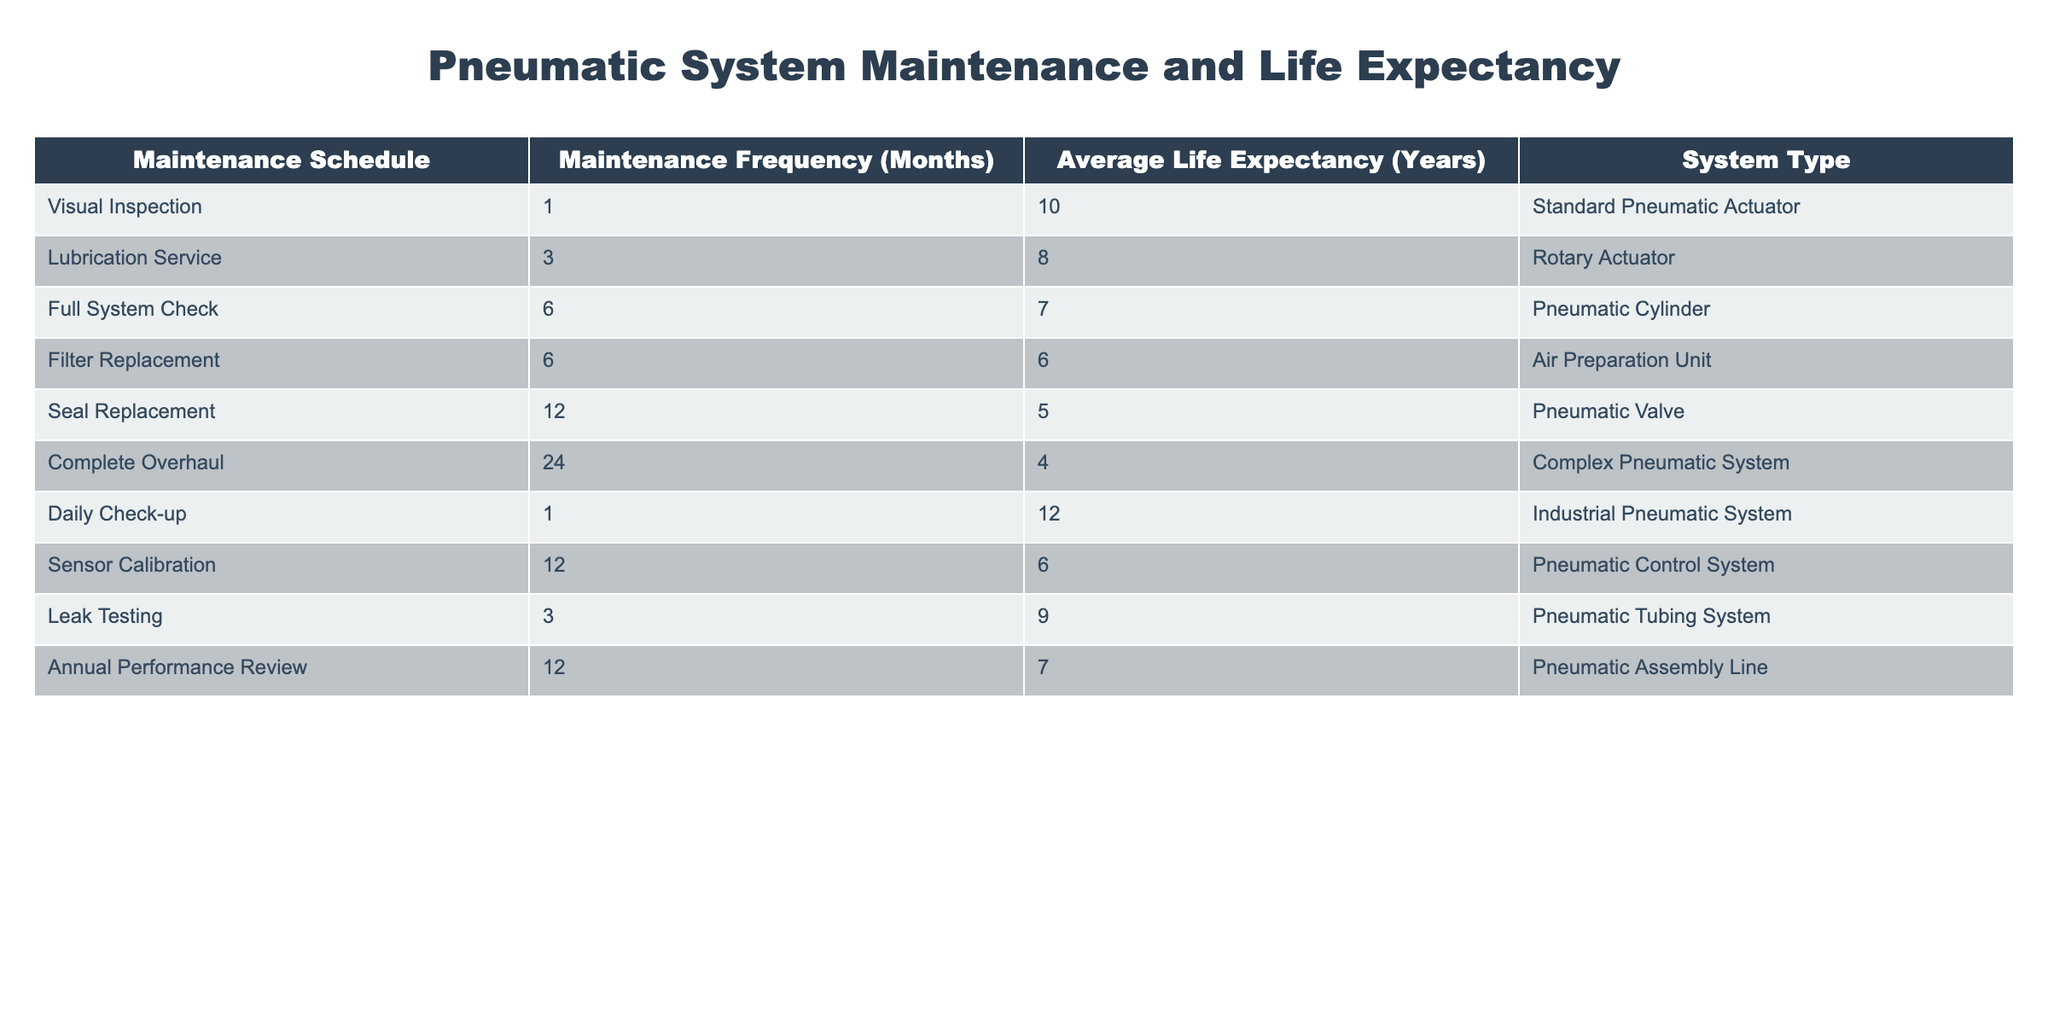What maintenance schedule has the longest average life expectancy? To find this, I will look at the "Average Life Expectancy (Years)" column and identify which maintenance schedule has the highest value. The Daily Check-up has an average life expectancy of 12 years, which is the greatest among all entries.
Answer: Daily Check-up What is the average life expectancy of pneumatic systems that require seal replacement? The only entry related to seal replacement shows an average life expectancy of 5 years. Since there is only one data point here, the average remains 5 years.
Answer: 5 years Is it true that a full system check every six months leads to a life expectancy of at least 7 years? According to the table, a full system check results in an average life expectancy of 7 years, meaning that the statement is true.
Answer: Yes How does the life expectancy of the industrial pneumatic system compare to that of the complex pneumatic system? The industrial pneumatic system has a life expectancy of 12 years, while the complex pneumatic system has a life expectancy of 4 years. To compare, 12 years is significantly higher than 4 years, indicating that the industrial system lasts much longer.
Answer: Industrial pneumatic system is greater What is the total life expectancy of all systems that require maintenance once a year or less? I will sum the life expectancies of all maintenance schedules that occur once a year or less: Daily Check-up (12) + Visual Inspection (10) + Leak Testing (9) + Lubrication Service (8) + Full System Check (7) + Annual Performance Review (7) = 12 + 10 + 9 + 8 + 7 + 7 = 53 years.
Answer: 53 years Which system type has the shortest life expectancy, and what is that expectancy? From the table, the complex pneumatic system has the shortest life expectancy of 4 years. This is indicated directly in the "Average Life Expectancy (Years)" column for that particular system type.
Answer: Complex Pneumatic System, 4 years What is the difference in life expectancy between the filter replacement and sensor calibration? The filter replacement has a life expectancy of 6 years while sensor calibration also has a life expectancy of 6 years. The difference between them is 6 - 6 = 0, indicating that both have the same expectancy.
Answer: 0 years How frequently should the lubrication service be performed compared to the complete overhaul to ensure longer life expectancy? Lubrication service should be performed every 3 months (frequency) and yields an average life expectancy of 8 years, while the complete overhaul is every 24 months with an average life expectancy of 4 years. This shows that lubrication service ensures a longer life expectancy by a margin of 4 years.
Answer: Lubrication service ensures longer expectancy 